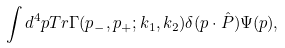<formula> <loc_0><loc_0><loc_500><loc_500>\int d ^ { 4 } p T r \Gamma ( p _ { - } , p _ { + } ; k _ { 1 } , k _ { 2 } ) \delta ( p \cdot \hat { P } ) \Psi ( p \mathbf { ) , }</formula> 